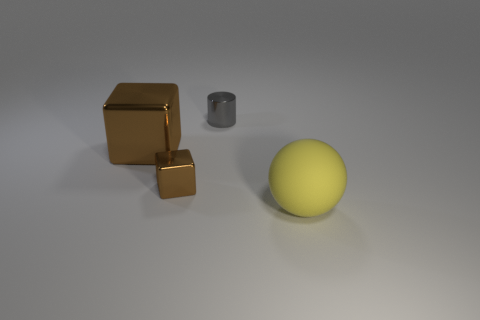There is a small object that is the same shape as the large brown object; what is it made of?
Your answer should be very brief. Metal. There is a block that is behind the small shiny object that is to the left of the small gray object; how big is it?
Ensure brevity in your answer.  Large. Are there any tiny yellow shiny cylinders?
Your answer should be compact. No. There is a thing that is both in front of the big cube and right of the small brown shiny object; what material is it?
Provide a succinct answer. Rubber. Are there more gray things behind the big metal cube than tiny cubes that are behind the tiny gray cylinder?
Your answer should be compact. Yes. Are there any brown cylinders that have the same size as the gray metal thing?
Provide a succinct answer. No. What size is the sphere in front of the brown cube behind the block in front of the large block?
Provide a succinct answer. Large. The big matte thing has what color?
Your answer should be very brief. Yellow. Is the number of brown objects left of the big yellow matte thing greater than the number of small metal cylinders?
Offer a terse response. Yes. There is a ball; what number of yellow matte things are behind it?
Offer a terse response. 0. 